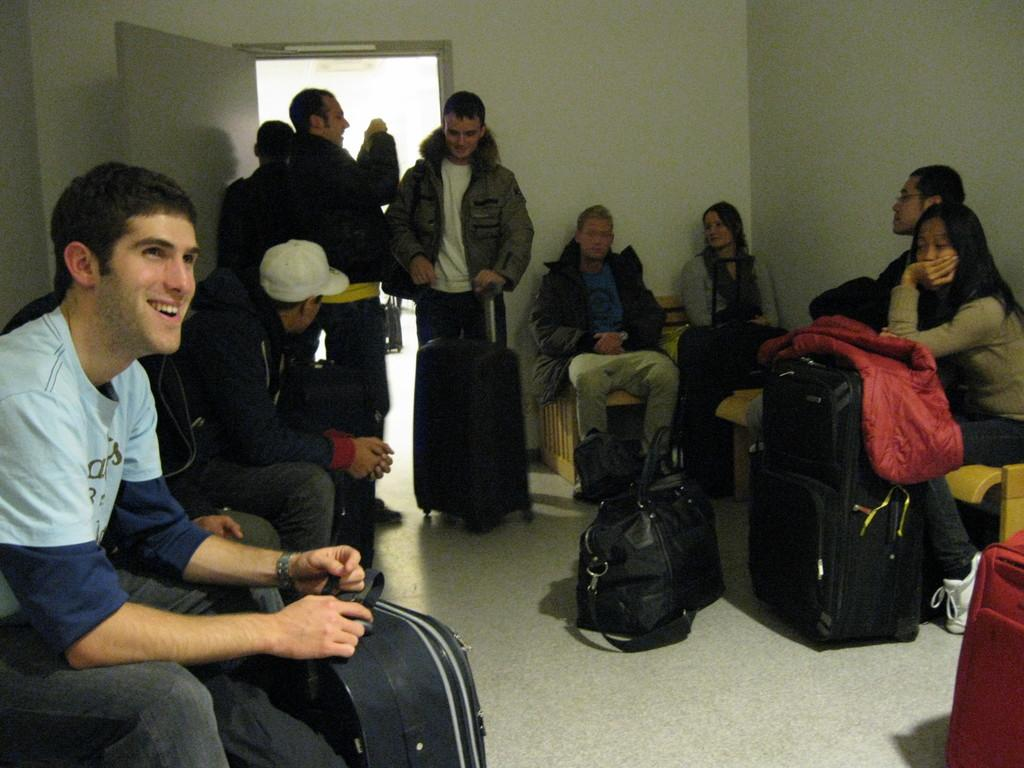What is the main activity of the people in the image? The people in the image are sitting. Are there any of all the people sitting, or are there any exceptions? Yes, there is at least one person standing in the image. What is the person standing doing? The person standing is holding luggage. Can you see a rabbit hopping around the people in the image? No, there is no rabbit present in the image. Is there a turkey helping the person standing with their luggage? No, there is no turkey present in the image, and the person standing is handling their luggage on their own. 